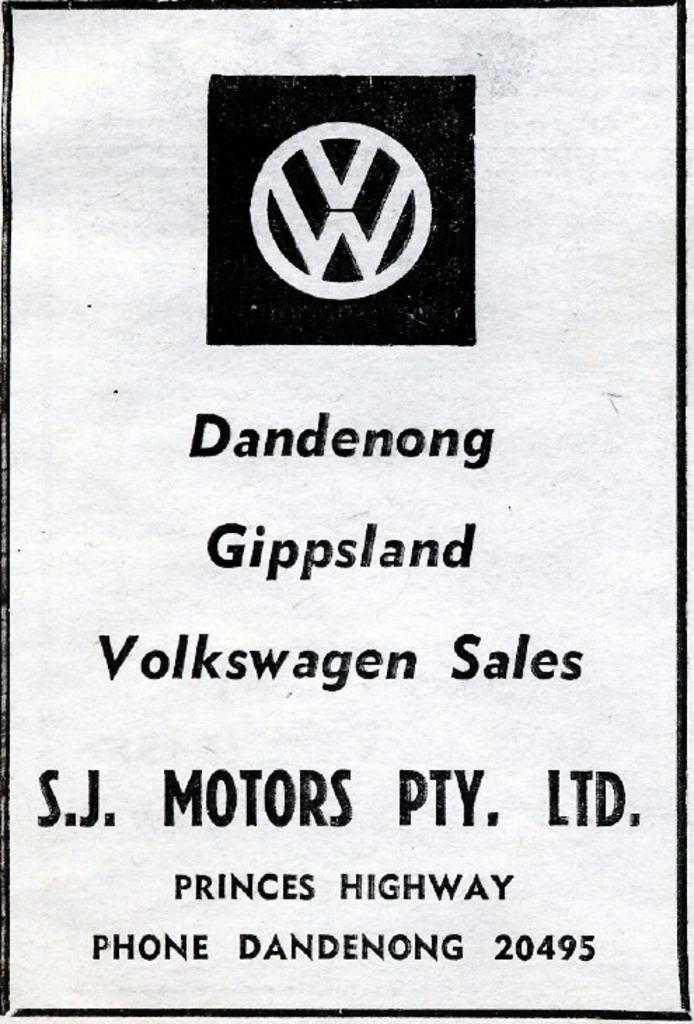Do i need to speak german to buy a car here?
Provide a short and direct response. Unanswerable. What is the name of the highway?
Your answer should be very brief. Princes. 